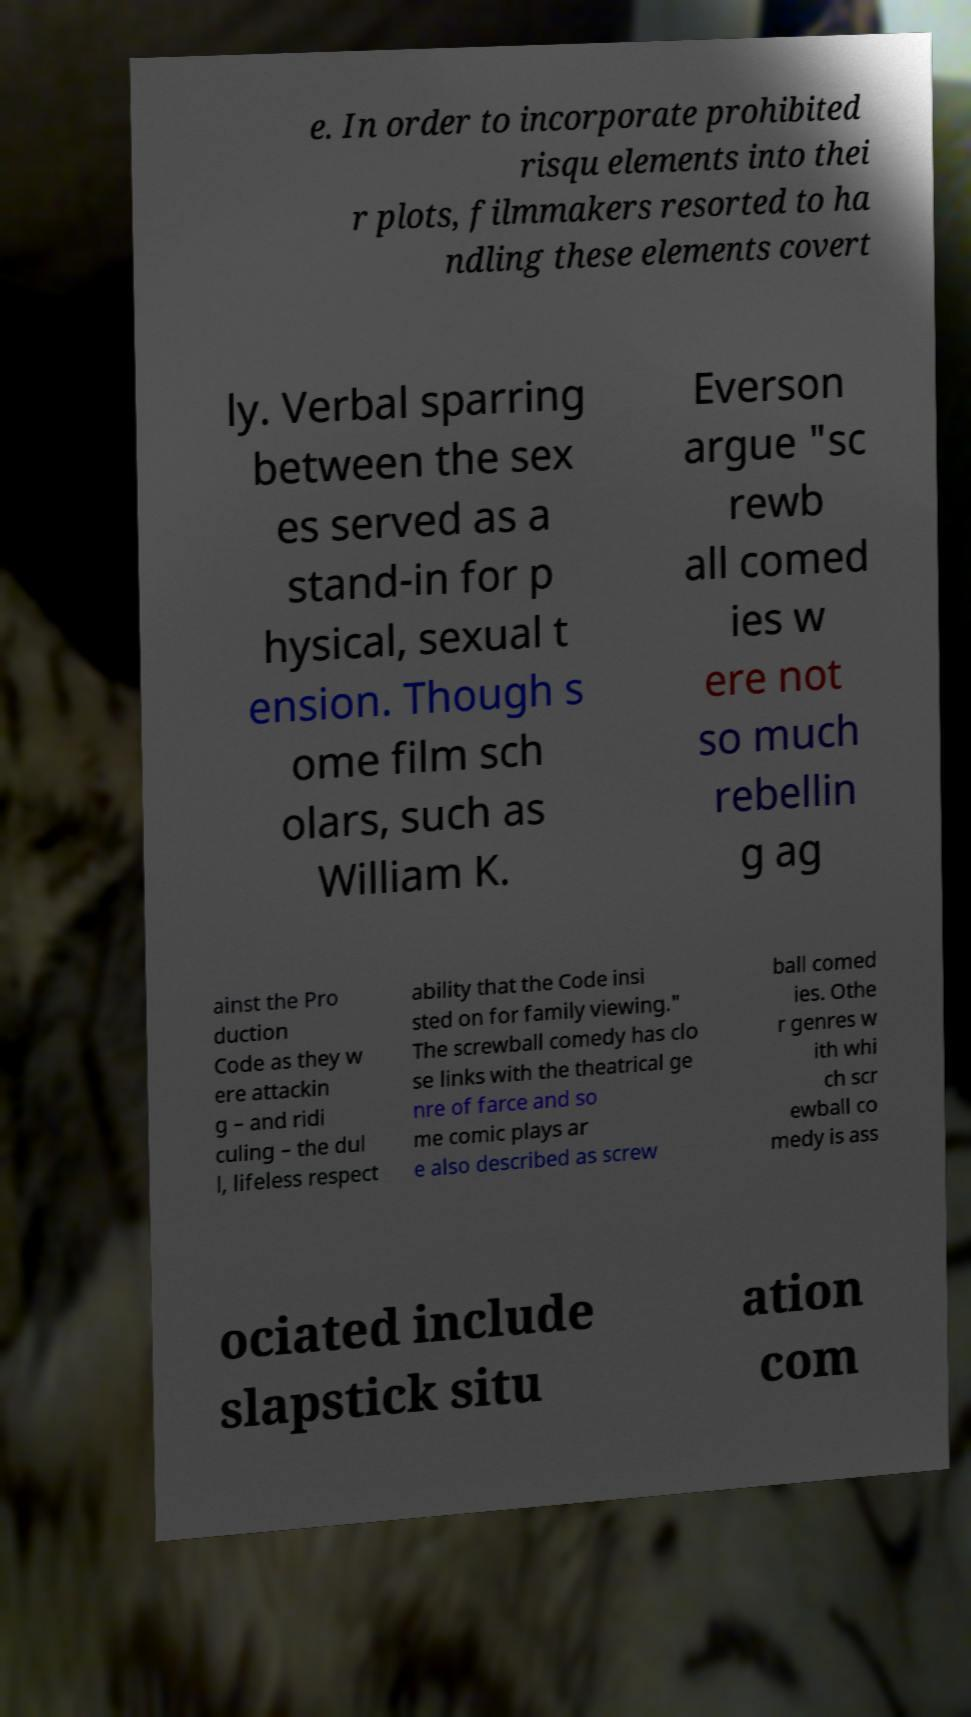Please identify and transcribe the text found in this image. e. In order to incorporate prohibited risqu elements into thei r plots, filmmakers resorted to ha ndling these elements covert ly. Verbal sparring between the sex es served as a stand-in for p hysical, sexual t ension. Though s ome film sch olars, such as William K. Everson argue "sc rewb all comed ies w ere not so much rebellin g ag ainst the Pro duction Code as they w ere attackin g – and ridi culing – the dul l, lifeless respect ability that the Code insi sted on for family viewing." The screwball comedy has clo se links with the theatrical ge nre of farce and so me comic plays ar e also described as screw ball comed ies. Othe r genres w ith whi ch scr ewball co medy is ass ociated include slapstick situ ation com 